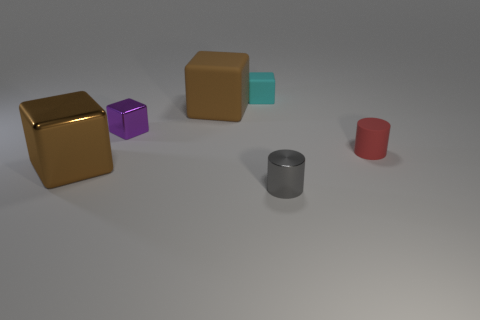There is a large brown rubber thing; is its shape the same as the matte thing that is right of the gray cylinder?
Your response must be concise. No. The object that is the same size as the brown matte block is what color?
Your response must be concise. Brown. Is the number of purple metallic cubes that are behind the tiny purple object less than the number of tiny red matte cylinders that are left of the tiny gray cylinder?
Provide a succinct answer. No. What shape is the tiny rubber object that is to the left of the cylinder that is left of the small rubber thing that is in front of the cyan rubber object?
Your answer should be compact. Cube. Do the shiny block that is in front of the red cylinder and the small metal thing that is behind the rubber cylinder have the same color?
Offer a very short reply. No. There is a big object that is the same color as the large metal block; what shape is it?
Offer a very short reply. Cube. What number of matte things are either tiny cyan objects or small objects?
Provide a short and direct response. 2. What is the color of the metallic block that is behind the small matte thing to the right of the block that is to the right of the brown matte thing?
Your answer should be very brief. Purple. There is a tiny shiny thing that is the same shape as the tiny red matte thing; what color is it?
Make the answer very short. Gray. Is there anything else that has the same color as the big matte block?
Provide a short and direct response. Yes. 